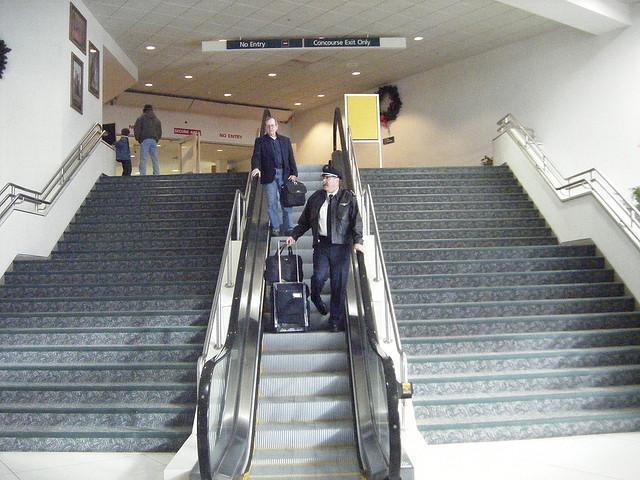How many people are in the picture?
Give a very brief answer. 2. How many sheep are there?
Give a very brief answer. 0. 